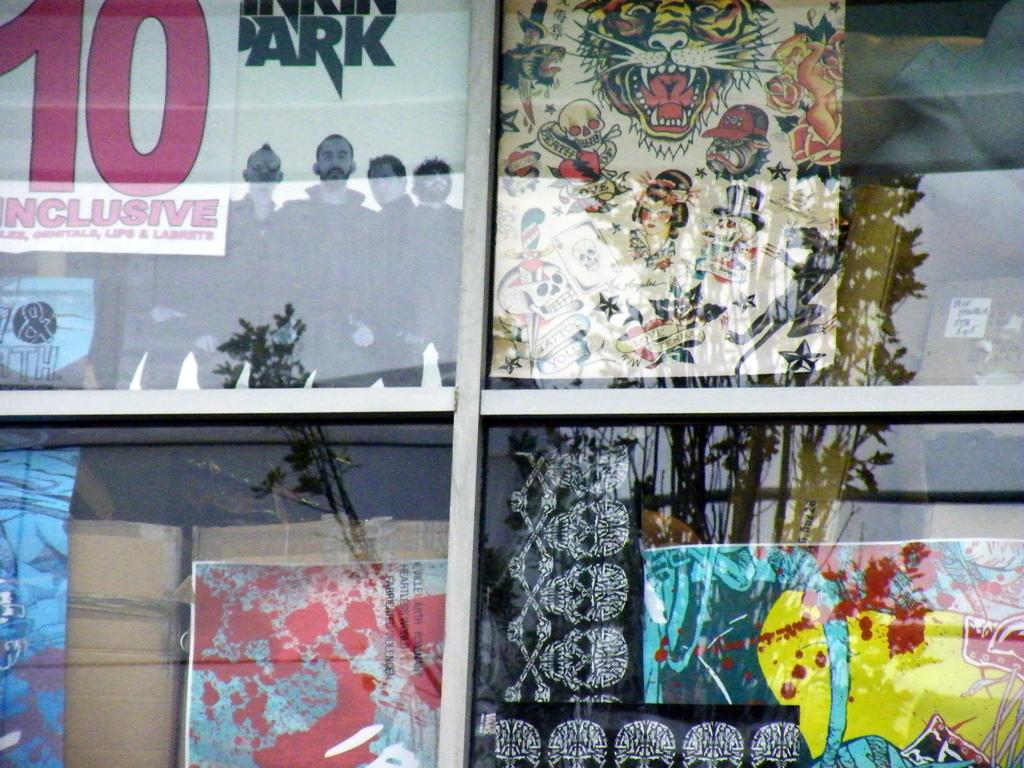What is present on the window in the image? There are window glasses in the image. What can be seen through the window glasses? Posters, carton boxes, and other objects are visible through the window glasses. Is there any reflection on the window glasses? Yes, there is a reflection of a tree on the window glasses. What type of string can be seen tied to the parcel in the image? There is no parcel or string present in the image. What book is the person reading in the image? There is no person reading a book in the image. 